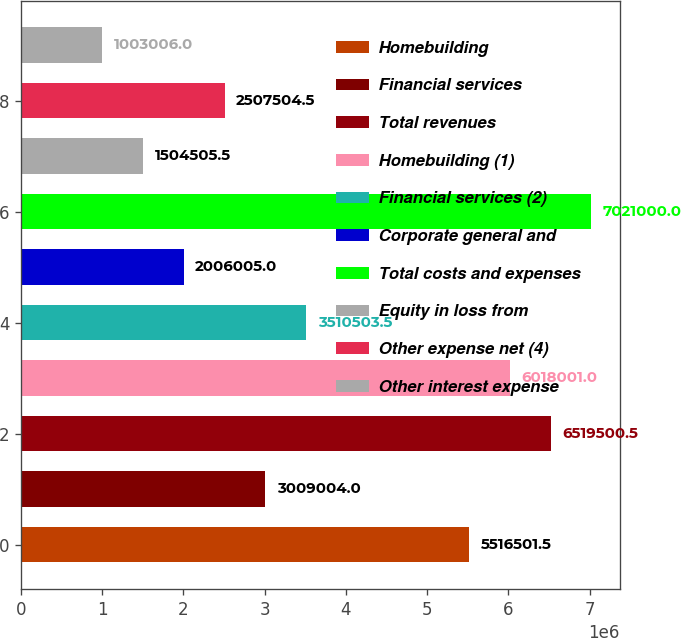Convert chart to OTSL. <chart><loc_0><loc_0><loc_500><loc_500><bar_chart><fcel>Homebuilding<fcel>Financial services<fcel>Total revenues<fcel>Homebuilding (1)<fcel>Financial services (2)<fcel>Corporate general and<fcel>Total costs and expenses<fcel>Equity in loss from<fcel>Other expense net (4)<fcel>Other interest expense<nl><fcel>5.5165e+06<fcel>3.009e+06<fcel>6.5195e+06<fcel>6.018e+06<fcel>3.5105e+06<fcel>2.006e+06<fcel>7.021e+06<fcel>1.50451e+06<fcel>2.5075e+06<fcel>1.00301e+06<nl></chart> 